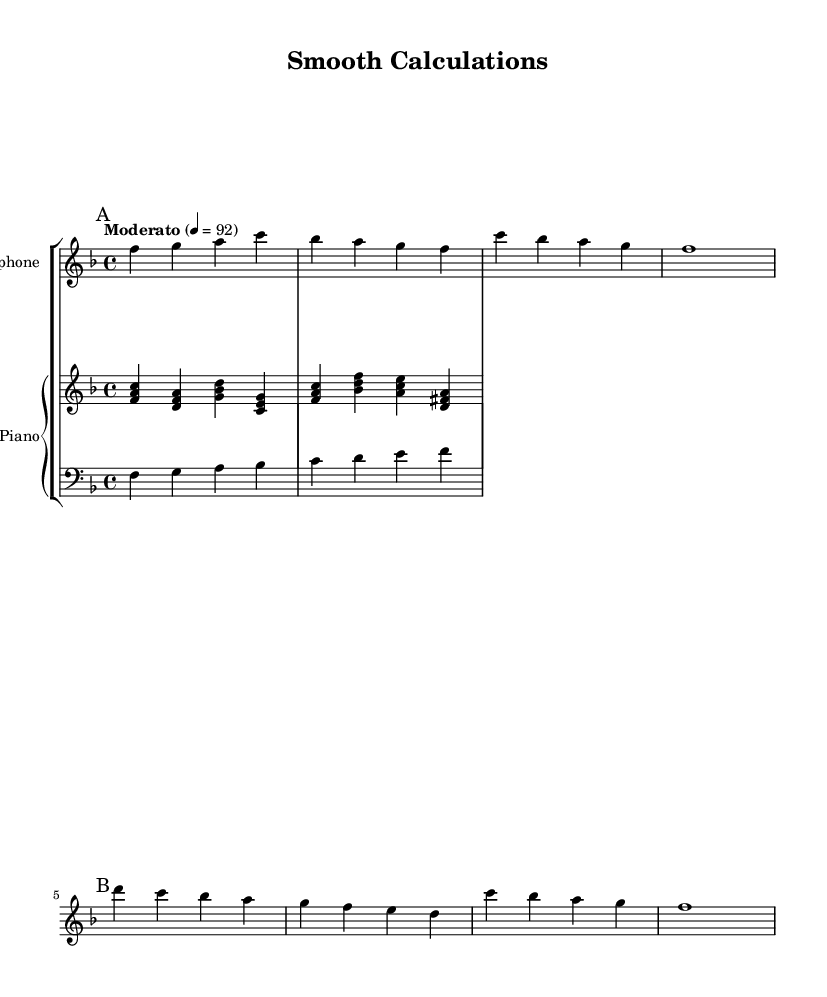What is the key signature of this music? The key signature, indicated at the beginning of the music, shows that there are one flat, which means it's in F major.
Answer: F major What is the time signature of this music? The time signature is marked as 4/4, which indicates there are four beats in each measure.
Answer: 4/4 What is the tempo marking of this piece? The tempo marking specifies "Moderato" with a tempo of 92 beats per minute, indicating a moderate pace for the performance.
Answer: Moderato, 92 How many measures are in section A? Section A contains four measures, as counted from the start up to the first marking "B."
Answer: 4 Which instrument plays the melody in section A? The melody in section A is primarily played by the saxophone as indicated in the score.
Answer: Saxophone What is the harmonic structure in the piano part during section A? The piano part uses chords built on the notes F, D, and G, creating a harmonic accompaniment for the melody.
Answer: F, D, G chords How does the bass line contribute to the overall feel of the piece? The bass line in the score provides a foundational harmonic support and rhythm, emphasizing the root notes that align with the chords in the piano part.
Answer: Provides foundation 